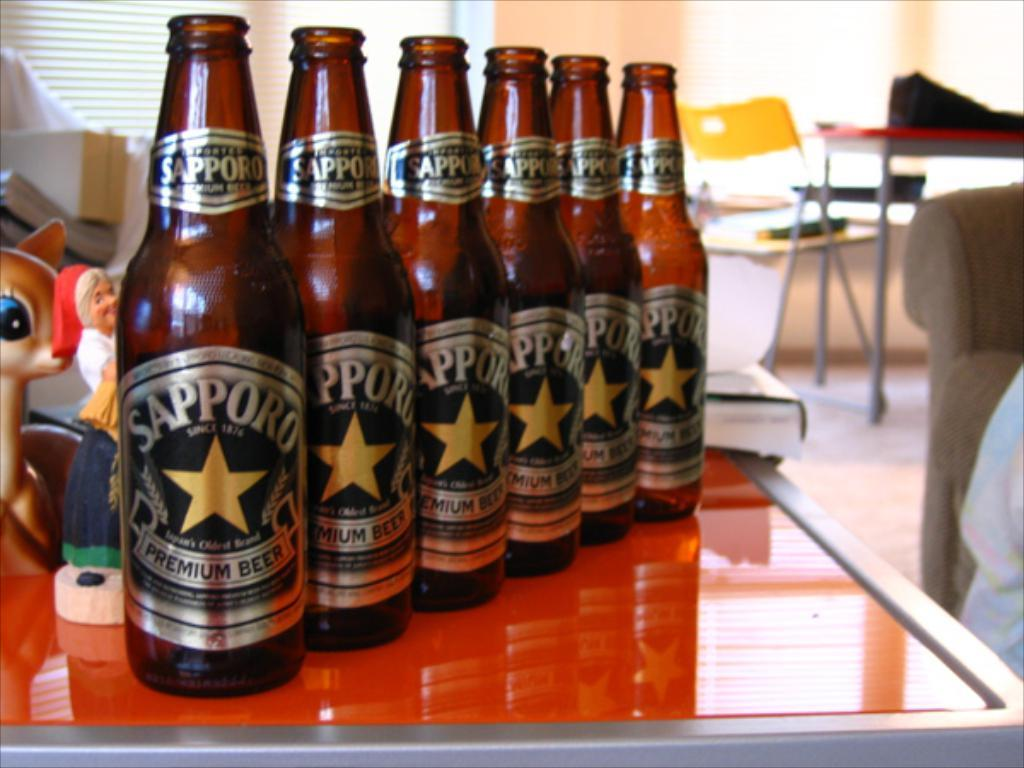<image>
Provide a brief description of the given image. Six bottles of Sapporo Premium beer on a table. 